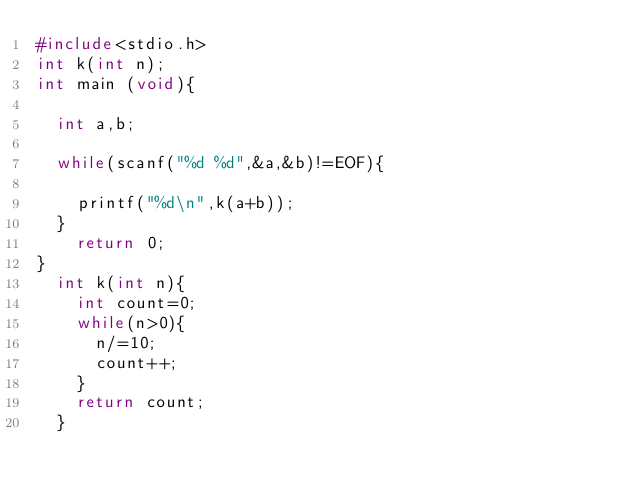<code> <loc_0><loc_0><loc_500><loc_500><_C_>#include<stdio.h>
int k(int n);
int main (void){
	
	int a,b;
	
	while(scanf("%d %d",&a,&b)!=EOF){
	  
		printf("%d\n",k(a+b));
	}
		return 0;
}
	int k(int n){
		int count=0;
		while(n>0){
			n/=10;
			count++;
		}
		return count;
	}
	</code> 